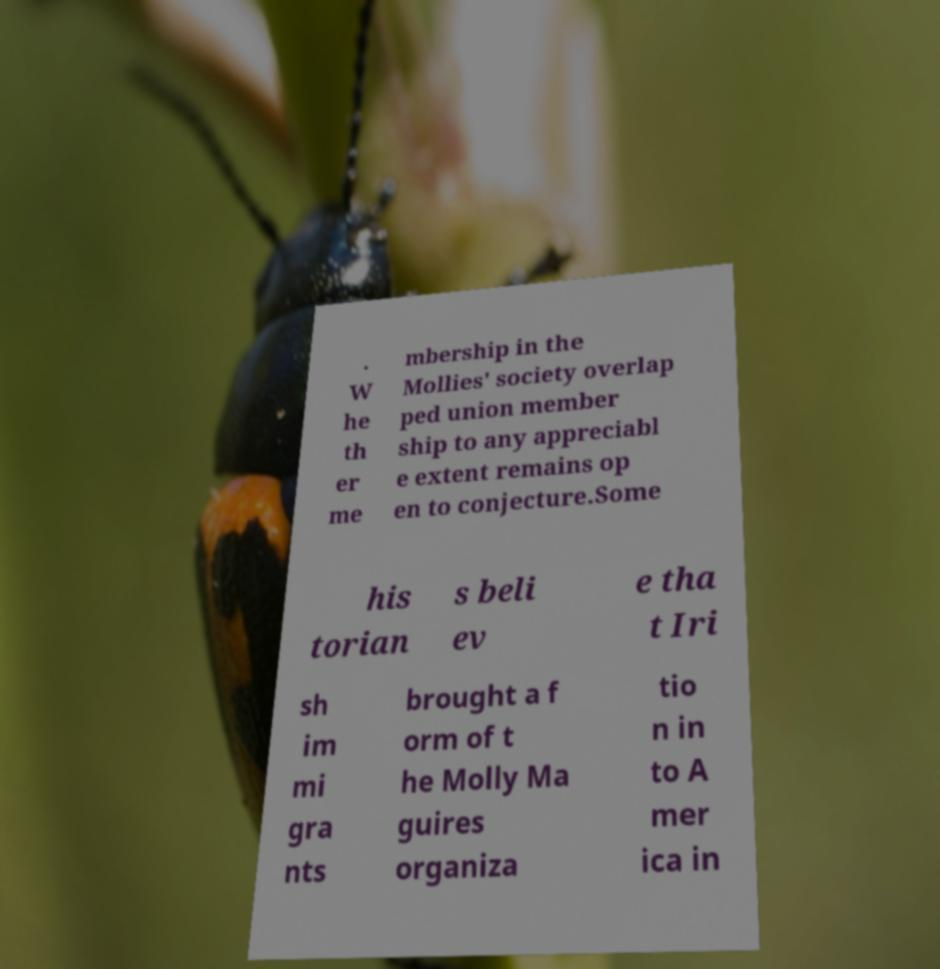Please identify and transcribe the text found in this image. . W he th er me mbership in the Mollies' society overlap ped union member ship to any appreciabl e extent remains op en to conjecture.Some his torian s beli ev e tha t Iri sh im mi gra nts brought a f orm of t he Molly Ma guires organiza tio n in to A mer ica in 